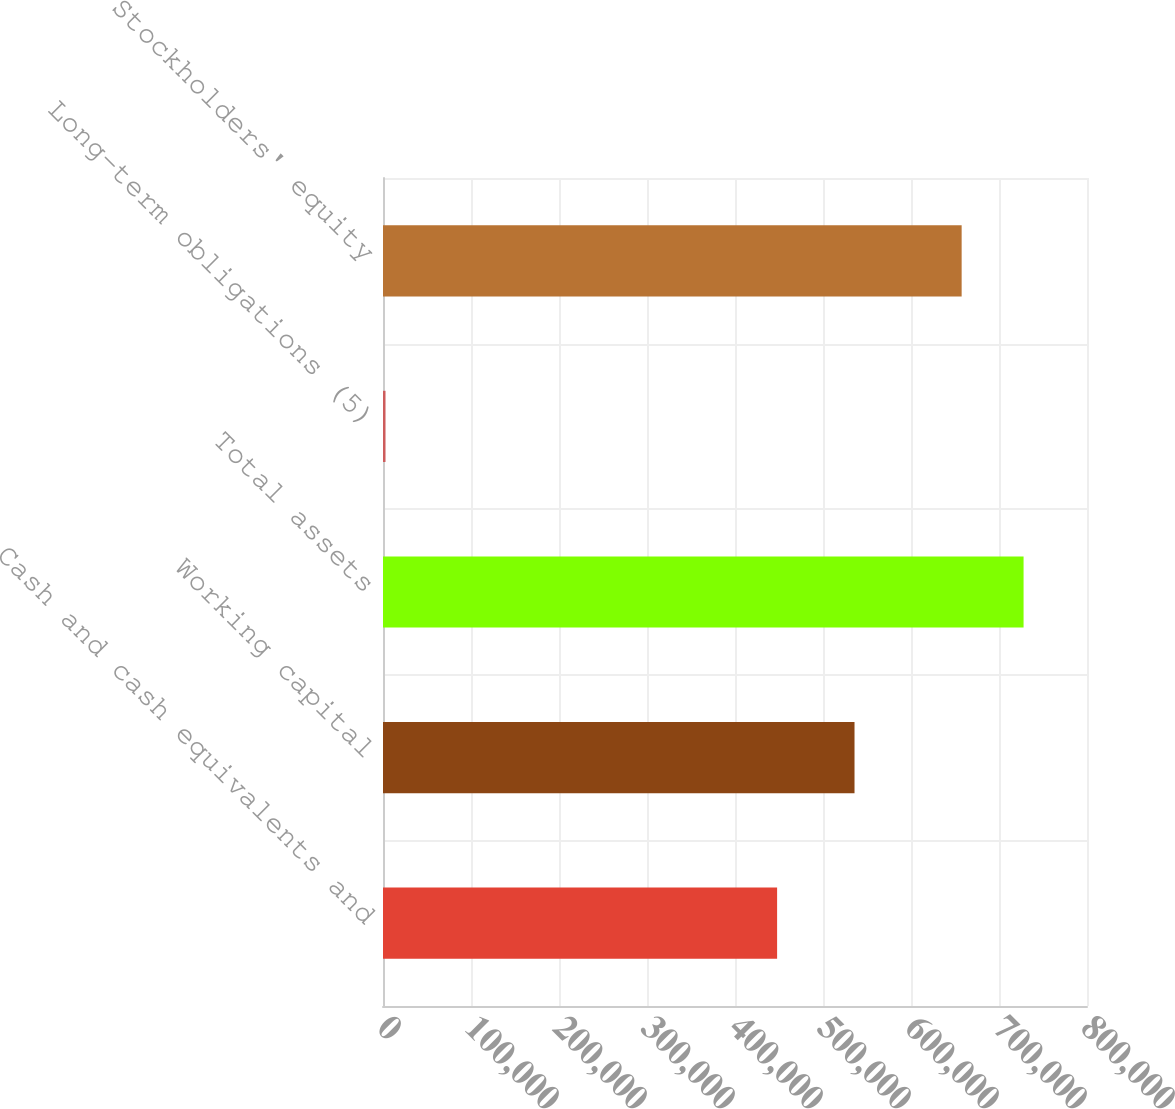Convert chart. <chart><loc_0><loc_0><loc_500><loc_500><bar_chart><fcel>Cash and cash equivalents and<fcel>Working capital<fcel>Total assets<fcel>Long-term obligations (5)<fcel>Stockholders' equity<nl><fcel>447848<fcel>535816<fcel>727925<fcel>2853<fcel>657557<nl></chart> 